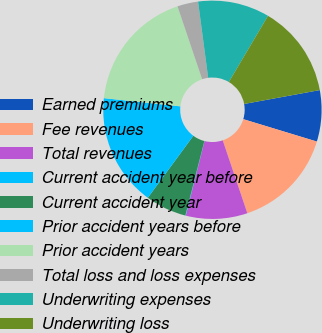Convert chart. <chart><loc_0><loc_0><loc_500><loc_500><pie_chart><fcel>Earned premiums<fcel>Fee revenues<fcel>Total revenues<fcel>Current accident year before<fcel>Current accident year<fcel>Prior accident years before<fcel>Prior accident years<fcel>Total loss and loss expenses<fcel>Underwriting expenses<fcel>Underwriting loss<nl><fcel>7.59%<fcel>15.12%<fcel>9.1%<fcel>0.07%<fcel>6.09%<fcel>16.62%<fcel>18.12%<fcel>3.08%<fcel>10.6%<fcel>13.61%<nl></chart> 